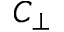Convert formula to latex. <formula><loc_0><loc_0><loc_500><loc_500>C _ { \perp }</formula> 